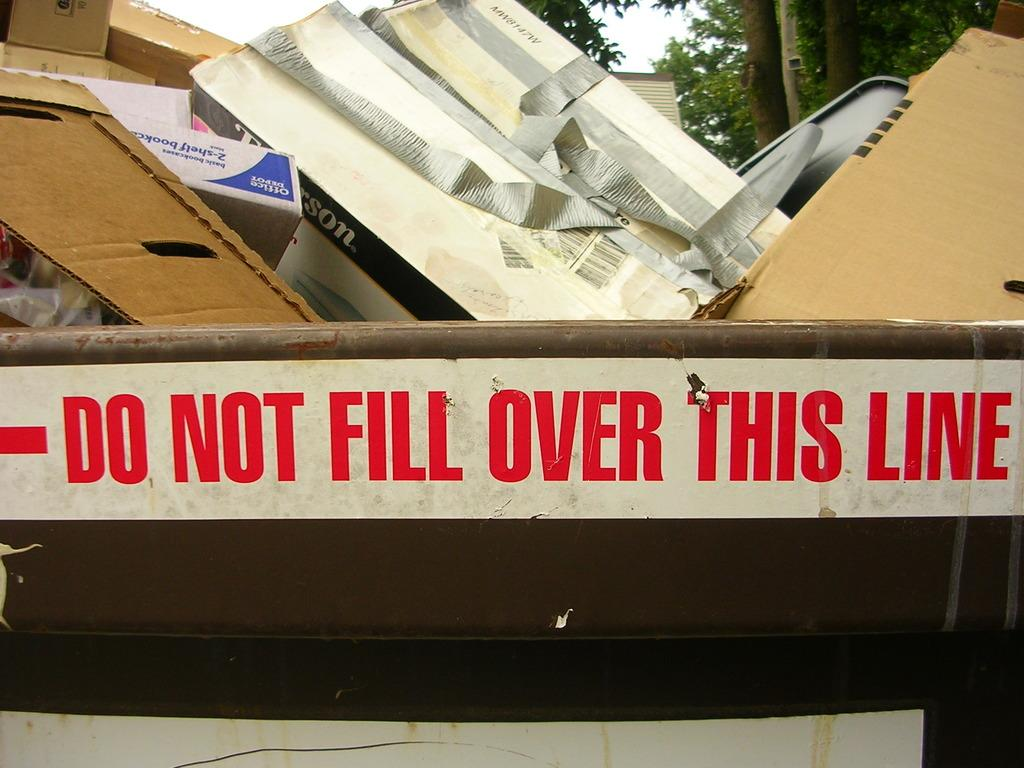Provide a one-sentence caption for the provided image. Do not fill over this line sign for a trash can. 